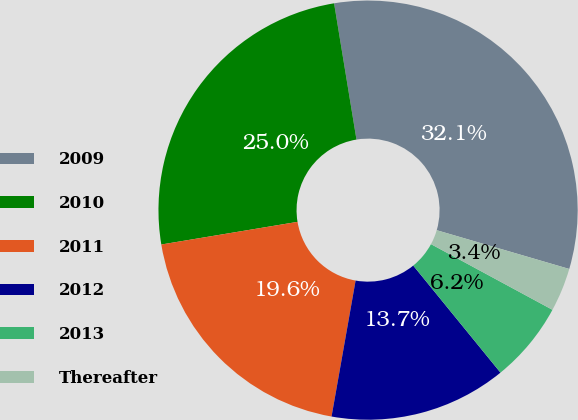<chart> <loc_0><loc_0><loc_500><loc_500><pie_chart><fcel>2009<fcel>2010<fcel>2011<fcel>2012<fcel>2013<fcel>Thereafter<nl><fcel>32.12%<fcel>25.03%<fcel>19.59%<fcel>13.67%<fcel>6.23%<fcel>3.36%<nl></chart> 